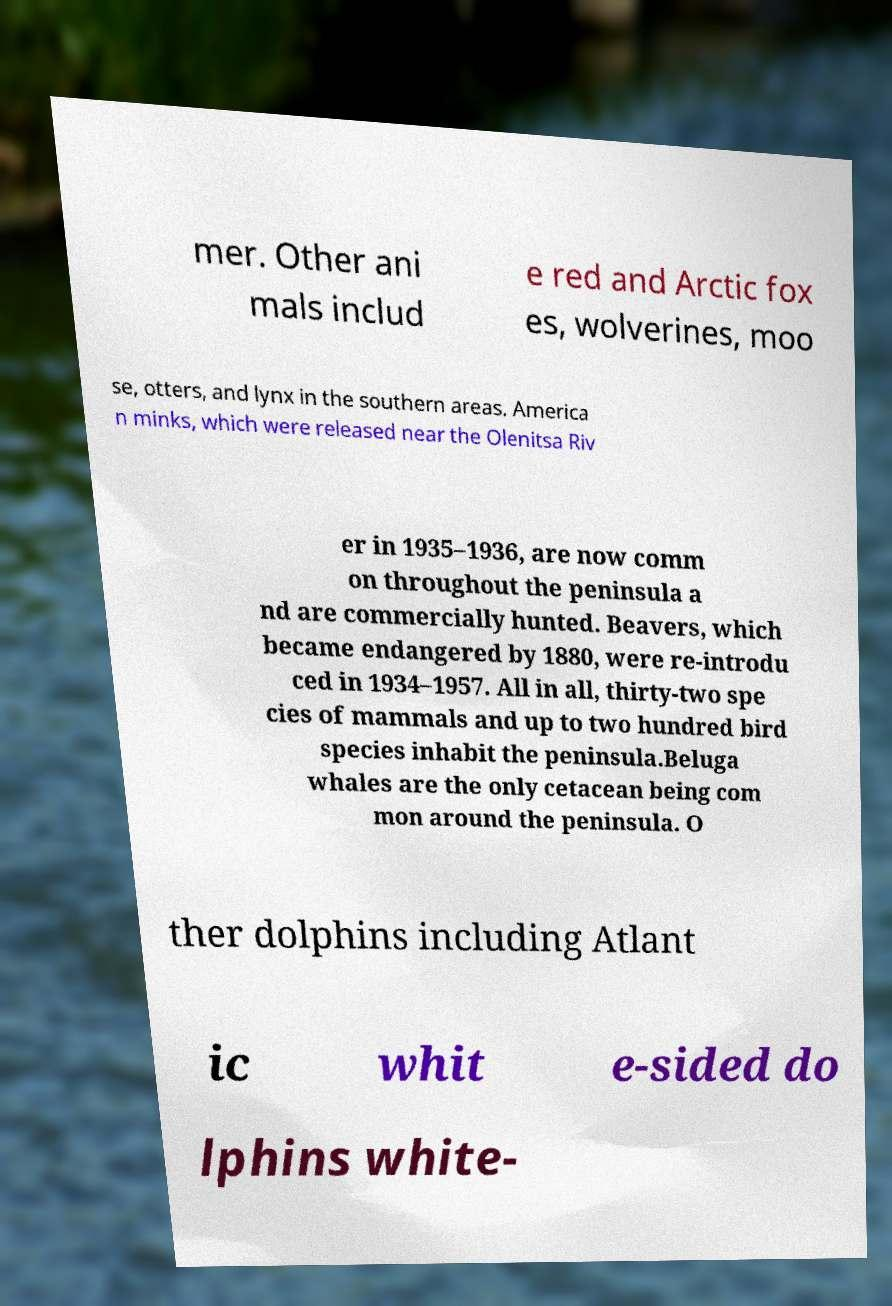Please read and relay the text visible in this image. What does it say? mer. Other ani mals includ e red and Arctic fox es, wolverines, moo se, otters, and lynx in the southern areas. America n minks, which were released near the Olenitsa Riv er in 1935–1936, are now comm on throughout the peninsula a nd are commercially hunted. Beavers, which became endangered by 1880, were re-introdu ced in 1934–1957. All in all, thirty-two spe cies of mammals and up to two hundred bird species inhabit the peninsula.Beluga whales are the only cetacean being com mon around the peninsula. O ther dolphins including Atlant ic whit e-sided do lphins white- 